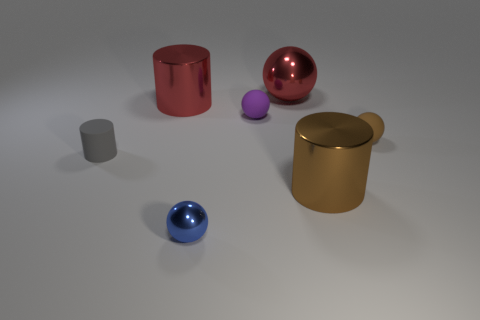If this were a photograph, what time of day does the lighting suggest? If this image were a photograph, the diffuse and soft lighting suggests it could be an overcast day, possibly midday when the light is even and shadows are minimal. 